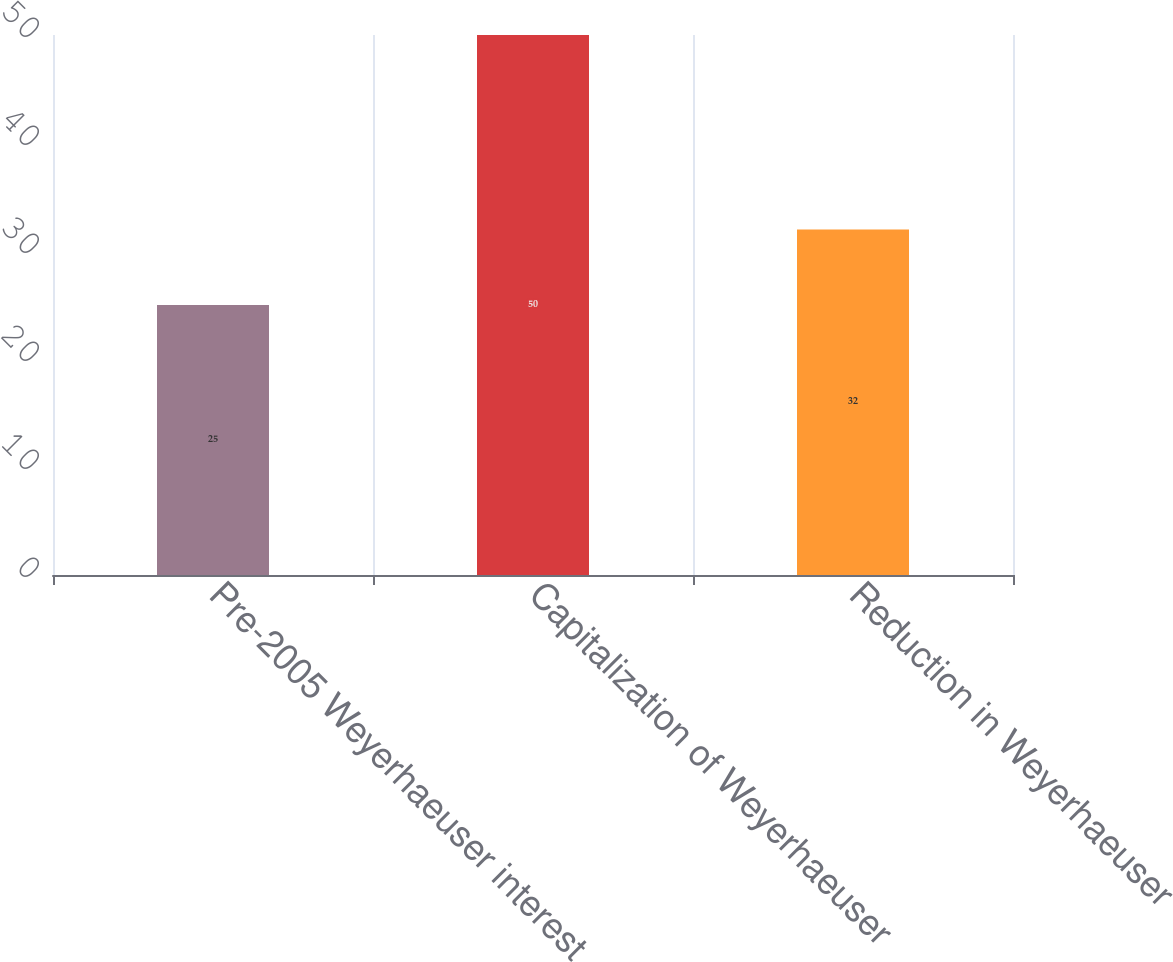Convert chart to OTSL. <chart><loc_0><loc_0><loc_500><loc_500><bar_chart><fcel>Pre-2005 Weyerhaeuser interest<fcel>Capitalization of Weyerhaeuser<fcel>Reduction in Weyerhaeuser<nl><fcel>25<fcel>50<fcel>32<nl></chart> 